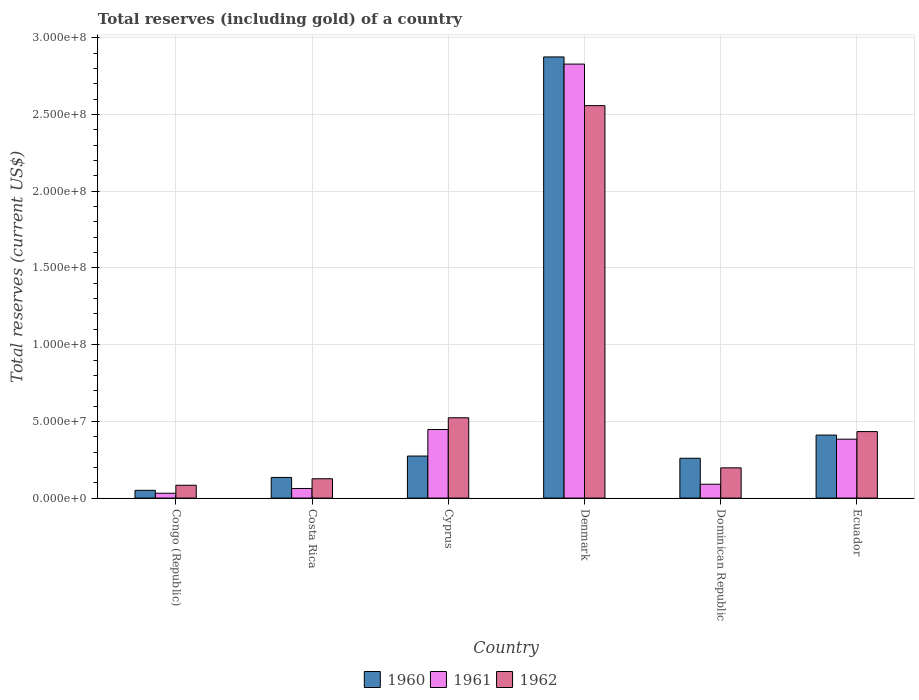How many different coloured bars are there?
Make the answer very short. 3. Are the number of bars on each tick of the X-axis equal?
Offer a terse response. Yes. How many bars are there on the 2nd tick from the right?
Offer a very short reply. 3. What is the label of the 5th group of bars from the left?
Make the answer very short. Dominican Republic. In how many cases, is the number of bars for a given country not equal to the number of legend labels?
Your response must be concise. 0. What is the total reserves (including gold) in 1961 in Denmark?
Your answer should be compact. 2.83e+08. Across all countries, what is the maximum total reserves (including gold) in 1960?
Offer a very short reply. 2.88e+08. Across all countries, what is the minimum total reserves (including gold) in 1960?
Offer a very short reply. 5.06e+06. In which country was the total reserves (including gold) in 1962 minimum?
Your response must be concise. Congo (Republic). What is the total total reserves (including gold) in 1960 in the graph?
Offer a terse response. 4.01e+08. What is the difference between the total reserves (including gold) in 1960 in Congo (Republic) and that in Cyprus?
Give a very brief answer. -2.23e+07. What is the difference between the total reserves (including gold) in 1961 in Ecuador and the total reserves (including gold) in 1962 in Denmark?
Your answer should be compact. -2.17e+08. What is the average total reserves (including gold) in 1961 per country?
Your response must be concise. 6.41e+07. What is the difference between the total reserves (including gold) of/in 1961 and total reserves (including gold) of/in 1962 in Costa Rica?
Offer a terse response. -6.34e+06. In how many countries, is the total reserves (including gold) in 1961 greater than 160000000 US$?
Give a very brief answer. 1. What is the ratio of the total reserves (including gold) in 1960 in Costa Rica to that in Cyprus?
Your answer should be very brief. 0.49. Is the difference between the total reserves (including gold) in 1961 in Denmark and Ecuador greater than the difference between the total reserves (including gold) in 1962 in Denmark and Ecuador?
Your response must be concise. Yes. What is the difference between the highest and the second highest total reserves (including gold) in 1962?
Your answer should be compact. -2.12e+08. What is the difference between the highest and the lowest total reserves (including gold) in 1961?
Ensure brevity in your answer.  2.80e+08. What does the 2nd bar from the right in Dominican Republic represents?
Give a very brief answer. 1961. How many bars are there?
Provide a succinct answer. 18. Are all the bars in the graph horizontal?
Give a very brief answer. No. What is the difference between two consecutive major ticks on the Y-axis?
Your response must be concise. 5.00e+07. Are the values on the major ticks of Y-axis written in scientific E-notation?
Offer a terse response. Yes. How are the legend labels stacked?
Offer a terse response. Horizontal. What is the title of the graph?
Ensure brevity in your answer.  Total reserves (including gold) of a country. What is the label or title of the X-axis?
Keep it short and to the point. Country. What is the label or title of the Y-axis?
Keep it short and to the point. Total reserves (current US$). What is the Total reserves (current US$) in 1960 in Congo (Republic)?
Provide a succinct answer. 5.06e+06. What is the Total reserves (current US$) of 1961 in Congo (Republic)?
Ensure brevity in your answer.  3.16e+06. What is the Total reserves (current US$) of 1962 in Congo (Republic)?
Your answer should be very brief. 8.38e+06. What is the Total reserves (current US$) of 1960 in Costa Rica?
Keep it short and to the point. 1.35e+07. What is the Total reserves (current US$) of 1961 in Costa Rica?
Give a very brief answer. 6.26e+06. What is the Total reserves (current US$) in 1962 in Costa Rica?
Offer a terse response. 1.26e+07. What is the Total reserves (current US$) in 1960 in Cyprus?
Give a very brief answer. 2.74e+07. What is the Total reserves (current US$) in 1961 in Cyprus?
Provide a short and direct response. 4.47e+07. What is the Total reserves (current US$) in 1962 in Cyprus?
Make the answer very short. 5.23e+07. What is the Total reserves (current US$) of 1960 in Denmark?
Ensure brevity in your answer.  2.88e+08. What is the Total reserves (current US$) in 1961 in Denmark?
Provide a succinct answer. 2.83e+08. What is the Total reserves (current US$) in 1962 in Denmark?
Give a very brief answer. 2.56e+08. What is the Total reserves (current US$) of 1960 in Dominican Republic?
Make the answer very short. 2.60e+07. What is the Total reserves (current US$) of 1961 in Dominican Republic?
Provide a short and direct response. 9.02e+06. What is the Total reserves (current US$) of 1962 in Dominican Republic?
Your answer should be very brief. 1.97e+07. What is the Total reserves (current US$) in 1960 in Ecuador?
Your response must be concise. 4.11e+07. What is the Total reserves (current US$) of 1961 in Ecuador?
Offer a terse response. 3.84e+07. What is the Total reserves (current US$) in 1962 in Ecuador?
Provide a succinct answer. 4.33e+07. Across all countries, what is the maximum Total reserves (current US$) in 1960?
Your answer should be compact. 2.88e+08. Across all countries, what is the maximum Total reserves (current US$) in 1961?
Give a very brief answer. 2.83e+08. Across all countries, what is the maximum Total reserves (current US$) in 1962?
Your response must be concise. 2.56e+08. Across all countries, what is the minimum Total reserves (current US$) of 1960?
Offer a very short reply. 5.06e+06. Across all countries, what is the minimum Total reserves (current US$) in 1961?
Make the answer very short. 3.16e+06. Across all countries, what is the minimum Total reserves (current US$) of 1962?
Your answer should be very brief. 8.38e+06. What is the total Total reserves (current US$) in 1960 in the graph?
Make the answer very short. 4.01e+08. What is the total Total reserves (current US$) of 1961 in the graph?
Provide a short and direct response. 3.84e+08. What is the total Total reserves (current US$) in 1962 in the graph?
Provide a succinct answer. 3.92e+08. What is the difference between the Total reserves (current US$) in 1960 in Congo (Republic) and that in Costa Rica?
Give a very brief answer. -8.40e+06. What is the difference between the Total reserves (current US$) in 1961 in Congo (Republic) and that in Costa Rica?
Give a very brief answer. -3.10e+06. What is the difference between the Total reserves (current US$) in 1962 in Congo (Republic) and that in Costa Rica?
Give a very brief answer. -4.22e+06. What is the difference between the Total reserves (current US$) in 1960 in Congo (Republic) and that in Cyprus?
Make the answer very short. -2.23e+07. What is the difference between the Total reserves (current US$) of 1961 in Congo (Republic) and that in Cyprus?
Your answer should be very brief. -4.15e+07. What is the difference between the Total reserves (current US$) of 1962 in Congo (Republic) and that in Cyprus?
Provide a short and direct response. -4.40e+07. What is the difference between the Total reserves (current US$) of 1960 in Congo (Republic) and that in Denmark?
Provide a short and direct response. -2.82e+08. What is the difference between the Total reserves (current US$) of 1961 in Congo (Republic) and that in Denmark?
Your response must be concise. -2.80e+08. What is the difference between the Total reserves (current US$) of 1962 in Congo (Republic) and that in Denmark?
Offer a very short reply. -2.47e+08. What is the difference between the Total reserves (current US$) of 1960 in Congo (Republic) and that in Dominican Republic?
Your answer should be compact. -2.09e+07. What is the difference between the Total reserves (current US$) in 1961 in Congo (Republic) and that in Dominican Republic?
Ensure brevity in your answer.  -5.86e+06. What is the difference between the Total reserves (current US$) in 1962 in Congo (Republic) and that in Dominican Republic?
Ensure brevity in your answer.  -1.13e+07. What is the difference between the Total reserves (current US$) in 1960 in Congo (Republic) and that in Ecuador?
Ensure brevity in your answer.  -3.60e+07. What is the difference between the Total reserves (current US$) in 1961 in Congo (Republic) and that in Ecuador?
Offer a very short reply. -3.52e+07. What is the difference between the Total reserves (current US$) in 1962 in Congo (Republic) and that in Ecuador?
Offer a very short reply. -3.50e+07. What is the difference between the Total reserves (current US$) of 1960 in Costa Rica and that in Cyprus?
Ensure brevity in your answer.  -1.39e+07. What is the difference between the Total reserves (current US$) in 1961 in Costa Rica and that in Cyprus?
Give a very brief answer. -3.84e+07. What is the difference between the Total reserves (current US$) in 1962 in Costa Rica and that in Cyprus?
Provide a succinct answer. -3.98e+07. What is the difference between the Total reserves (current US$) in 1960 in Costa Rica and that in Denmark?
Offer a very short reply. -2.74e+08. What is the difference between the Total reserves (current US$) of 1961 in Costa Rica and that in Denmark?
Offer a very short reply. -2.77e+08. What is the difference between the Total reserves (current US$) in 1962 in Costa Rica and that in Denmark?
Your answer should be very brief. -2.43e+08. What is the difference between the Total reserves (current US$) in 1960 in Costa Rica and that in Dominican Republic?
Your response must be concise. -1.25e+07. What is the difference between the Total reserves (current US$) of 1961 in Costa Rica and that in Dominican Republic?
Offer a very short reply. -2.76e+06. What is the difference between the Total reserves (current US$) of 1962 in Costa Rica and that in Dominican Republic?
Keep it short and to the point. -7.12e+06. What is the difference between the Total reserves (current US$) in 1960 in Costa Rica and that in Ecuador?
Make the answer very short. -2.76e+07. What is the difference between the Total reserves (current US$) in 1961 in Costa Rica and that in Ecuador?
Offer a terse response. -3.21e+07. What is the difference between the Total reserves (current US$) in 1962 in Costa Rica and that in Ecuador?
Provide a succinct answer. -3.07e+07. What is the difference between the Total reserves (current US$) in 1960 in Cyprus and that in Denmark?
Provide a short and direct response. -2.60e+08. What is the difference between the Total reserves (current US$) of 1961 in Cyprus and that in Denmark?
Offer a very short reply. -2.38e+08. What is the difference between the Total reserves (current US$) of 1962 in Cyprus and that in Denmark?
Your response must be concise. -2.03e+08. What is the difference between the Total reserves (current US$) of 1960 in Cyprus and that in Dominican Republic?
Your response must be concise. 1.43e+06. What is the difference between the Total reserves (current US$) in 1961 in Cyprus and that in Dominican Republic?
Keep it short and to the point. 3.57e+07. What is the difference between the Total reserves (current US$) of 1962 in Cyprus and that in Dominican Republic?
Provide a short and direct response. 3.26e+07. What is the difference between the Total reserves (current US$) in 1960 in Cyprus and that in Ecuador?
Provide a succinct answer. -1.37e+07. What is the difference between the Total reserves (current US$) of 1961 in Cyprus and that in Ecuador?
Your answer should be compact. 6.30e+06. What is the difference between the Total reserves (current US$) of 1962 in Cyprus and that in Ecuador?
Ensure brevity in your answer.  9.00e+06. What is the difference between the Total reserves (current US$) in 1960 in Denmark and that in Dominican Republic?
Offer a terse response. 2.62e+08. What is the difference between the Total reserves (current US$) of 1961 in Denmark and that in Dominican Republic?
Make the answer very short. 2.74e+08. What is the difference between the Total reserves (current US$) in 1962 in Denmark and that in Dominican Republic?
Your answer should be very brief. 2.36e+08. What is the difference between the Total reserves (current US$) of 1960 in Denmark and that in Ecuador?
Provide a succinct answer. 2.46e+08. What is the difference between the Total reserves (current US$) of 1961 in Denmark and that in Ecuador?
Provide a short and direct response. 2.44e+08. What is the difference between the Total reserves (current US$) of 1962 in Denmark and that in Ecuador?
Make the answer very short. 2.12e+08. What is the difference between the Total reserves (current US$) in 1960 in Dominican Republic and that in Ecuador?
Keep it short and to the point. -1.51e+07. What is the difference between the Total reserves (current US$) of 1961 in Dominican Republic and that in Ecuador?
Offer a terse response. -2.94e+07. What is the difference between the Total reserves (current US$) in 1962 in Dominican Republic and that in Ecuador?
Offer a terse response. -2.36e+07. What is the difference between the Total reserves (current US$) in 1960 in Congo (Republic) and the Total reserves (current US$) in 1961 in Costa Rica?
Give a very brief answer. -1.20e+06. What is the difference between the Total reserves (current US$) in 1960 in Congo (Republic) and the Total reserves (current US$) in 1962 in Costa Rica?
Ensure brevity in your answer.  -7.54e+06. What is the difference between the Total reserves (current US$) of 1961 in Congo (Republic) and the Total reserves (current US$) of 1962 in Costa Rica?
Your response must be concise. -9.44e+06. What is the difference between the Total reserves (current US$) of 1960 in Congo (Republic) and the Total reserves (current US$) of 1961 in Cyprus?
Ensure brevity in your answer.  -3.96e+07. What is the difference between the Total reserves (current US$) in 1960 in Congo (Republic) and the Total reserves (current US$) in 1962 in Cyprus?
Your response must be concise. -4.73e+07. What is the difference between the Total reserves (current US$) of 1961 in Congo (Republic) and the Total reserves (current US$) of 1962 in Cyprus?
Offer a very short reply. -4.92e+07. What is the difference between the Total reserves (current US$) of 1960 in Congo (Republic) and the Total reserves (current US$) of 1961 in Denmark?
Make the answer very short. -2.78e+08. What is the difference between the Total reserves (current US$) in 1960 in Congo (Republic) and the Total reserves (current US$) in 1962 in Denmark?
Your answer should be very brief. -2.51e+08. What is the difference between the Total reserves (current US$) in 1961 in Congo (Republic) and the Total reserves (current US$) in 1962 in Denmark?
Ensure brevity in your answer.  -2.53e+08. What is the difference between the Total reserves (current US$) in 1960 in Congo (Republic) and the Total reserves (current US$) in 1961 in Dominican Republic?
Offer a very short reply. -3.96e+06. What is the difference between the Total reserves (current US$) in 1960 in Congo (Republic) and the Total reserves (current US$) in 1962 in Dominican Republic?
Make the answer very short. -1.47e+07. What is the difference between the Total reserves (current US$) of 1961 in Congo (Republic) and the Total reserves (current US$) of 1962 in Dominican Republic?
Offer a very short reply. -1.66e+07. What is the difference between the Total reserves (current US$) of 1960 in Congo (Republic) and the Total reserves (current US$) of 1961 in Ecuador?
Your answer should be very brief. -3.33e+07. What is the difference between the Total reserves (current US$) of 1960 in Congo (Republic) and the Total reserves (current US$) of 1962 in Ecuador?
Your answer should be compact. -3.83e+07. What is the difference between the Total reserves (current US$) of 1961 in Congo (Republic) and the Total reserves (current US$) of 1962 in Ecuador?
Your response must be concise. -4.02e+07. What is the difference between the Total reserves (current US$) of 1960 in Costa Rica and the Total reserves (current US$) of 1961 in Cyprus?
Your response must be concise. -3.12e+07. What is the difference between the Total reserves (current US$) in 1960 in Costa Rica and the Total reserves (current US$) in 1962 in Cyprus?
Make the answer very short. -3.89e+07. What is the difference between the Total reserves (current US$) of 1961 in Costa Rica and the Total reserves (current US$) of 1962 in Cyprus?
Give a very brief answer. -4.61e+07. What is the difference between the Total reserves (current US$) in 1960 in Costa Rica and the Total reserves (current US$) in 1961 in Denmark?
Offer a very short reply. -2.69e+08. What is the difference between the Total reserves (current US$) in 1960 in Costa Rica and the Total reserves (current US$) in 1962 in Denmark?
Keep it short and to the point. -2.42e+08. What is the difference between the Total reserves (current US$) in 1961 in Costa Rica and the Total reserves (current US$) in 1962 in Denmark?
Ensure brevity in your answer.  -2.50e+08. What is the difference between the Total reserves (current US$) in 1960 in Costa Rica and the Total reserves (current US$) in 1961 in Dominican Republic?
Your answer should be very brief. 4.44e+06. What is the difference between the Total reserves (current US$) of 1960 in Costa Rica and the Total reserves (current US$) of 1962 in Dominican Republic?
Ensure brevity in your answer.  -6.26e+06. What is the difference between the Total reserves (current US$) of 1961 in Costa Rica and the Total reserves (current US$) of 1962 in Dominican Republic?
Your answer should be compact. -1.35e+07. What is the difference between the Total reserves (current US$) in 1960 in Costa Rica and the Total reserves (current US$) in 1961 in Ecuador?
Your response must be concise. -2.49e+07. What is the difference between the Total reserves (current US$) of 1960 in Costa Rica and the Total reserves (current US$) of 1962 in Ecuador?
Your answer should be very brief. -2.99e+07. What is the difference between the Total reserves (current US$) in 1961 in Costa Rica and the Total reserves (current US$) in 1962 in Ecuador?
Offer a terse response. -3.71e+07. What is the difference between the Total reserves (current US$) in 1960 in Cyprus and the Total reserves (current US$) in 1961 in Denmark?
Give a very brief answer. -2.55e+08. What is the difference between the Total reserves (current US$) of 1960 in Cyprus and the Total reserves (current US$) of 1962 in Denmark?
Your answer should be very brief. -2.28e+08. What is the difference between the Total reserves (current US$) in 1961 in Cyprus and the Total reserves (current US$) in 1962 in Denmark?
Keep it short and to the point. -2.11e+08. What is the difference between the Total reserves (current US$) of 1960 in Cyprus and the Total reserves (current US$) of 1961 in Dominican Republic?
Make the answer very short. 1.84e+07. What is the difference between the Total reserves (current US$) in 1960 in Cyprus and the Total reserves (current US$) in 1962 in Dominican Republic?
Your answer should be very brief. 7.68e+06. What is the difference between the Total reserves (current US$) in 1961 in Cyprus and the Total reserves (current US$) in 1962 in Dominican Republic?
Make the answer very short. 2.50e+07. What is the difference between the Total reserves (current US$) in 1960 in Cyprus and the Total reserves (current US$) in 1961 in Ecuador?
Provide a succinct answer. -1.10e+07. What is the difference between the Total reserves (current US$) of 1960 in Cyprus and the Total reserves (current US$) of 1962 in Ecuador?
Ensure brevity in your answer.  -1.59e+07. What is the difference between the Total reserves (current US$) of 1961 in Cyprus and the Total reserves (current US$) of 1962 in Ecuador?
Your answer should be very brief. 1.35e+06. What is the difference between the Total reserves (current US$) of 1960 in Denmark and the Total reserves (current US$) of 1961 in Dominican Republic?
Make the answer very short. 2.79e+08. What is the difference between the Total reserves (current US$) in 1960 in Denmark and the Total reserves (current US$) in 1962 in Dominican Republic?
Your answer should be very brief. 2.68e+08. What is the difference between the Total reserves (current US$) of 1961 in Denmark and the Total reserves (current US$) of 1962 in Dominican Republic?
Keep it short and to the point. 2.63e+08. What is the difference between the Total reserves (current US$) of 1960 in Denmark and the Total reserves (current US$) of 1961 in Ecuador?
Keep it short and to the point. 2.49e+08. What is the difference between the Total reserves (current US$) in 1960 in Denmark and the Total reserves (current US$) in 1962 in Ecuador?
Keep it short and to the point. 2.44e+08. What is the difference between the Total reserves (current US$) in 1961 in Denmark and the Total reserves (current US$) in 1962 in Ecuador?
Make the answer very short. 2.40e+08. What is the difference between the Total reserves (current US$) in 1960 in Dominican Republic and the Total reserves (current US$) in 1961 in Ecuador?
Offer a very short reply. -1.24e+07. What is the difference between the Total reserves (current US$) in 1960 in Dominican Republic and the Total reserves (current US$) in 1962 in Ecuador?
Your answer should be very brief. -1.74e+07. What is the difference between the Total reserves (current US$) in 1961 in Dominican Republic and the Total reserves (current US$) in 1962 in Ecuador?
Your answer should be very brief. -3.43e+07. What is the average Total reserves (current US$) of 1960 per country?
Provide a succinct answer. 6.68e+07. What is the average Total reserves (current US$) of 1961 per country?
Ensure brevity in your answer.  6.41e+07. What is the average Total reserves (current US$) in 1962 per country?
Offer a very short reply. 6.54e+07. What is the difference between the Total reserves (current US$) of 1960 and Total reserves (current US$) of 1961 in Congo (Republic)?
Give a very brief answer. 1.90e+06. What is the difference between the Total reserves (current US$) of 1960 and Total reserves (current US$) of 1962 in Congo (Republic)?
Ensure brevity in your answer.  -3.32e+06. What is the difference between the Total reserves (current US$) in 1961 and Total reserves (current US$) in 1962 in Congo (Republic)?
Your response must be concise. -5.22e+06. What is the difference between the Total reserves (current US$) in 1960 and Total reserves (current US$) in 1961 in Costa Rica?
Provide a short and direct response. 7.20e+06. What is the difference between the Total reserves (current US$) of 1960 and Total reserves (current US$) of 1962 in Costa Rica?
Make the answer very short. 8.62e+05. What is the difference between the Total reserves (current US$) of 1961 and Total reserves (current US$) of 1962 in Costa Rica?
Provide a succinct answer. -6.34e+06. What is the difference between the Total reserves (current US$) of 1960 and Total reserves (current US$) of 1961 in Cyprus?
Give a very brief answer. -1.73e+07. What is the difference between the Total reserves (current US$) in 1960 and Total reserves (current US$) in 1962 in Cyprus?
Keep it short and to the point. -2.49e+07. What is the difference between the Total reserves (current US$) of 1961 and Total reserves (current US$) of 1962 in Cyprus?
Offer a terse response. -7.65e+06. What is the difference between the Total reserves (current US$) in 1960 and Total reserves (current US$) in 1961 in Denmark?
Provide a succinct answer. 4.67e+06. What is the difference between the Total reserves (current US$) of 1960 and Total reserves (current US$) of 1962 in Denmark?
Offer a very short reply. 3.17e+07. What is the difference between the Total reserves (current US$) in 1961 and Total reserves (current US$) in 1962 in Denmark?
Offer a very short reply. 2.71e+07. What is the difference between the Total reserves (current US$) in 1960 and Total reserves (current US$) in 1961 in Dominican Republic?
Your answer should be very brief. 1.70e+07. What is the difference between the Total reserves (current US$) of 1960 and Total reserves (current US$) of 1962 in Dominican Republic?
Your response must be concise. 6.26e+06. What is the difference between the Total reserves (current US$) of 1961 and Total reserves (current US$) of 1962 in Dominican Republic?
Keep it short and to the point. -1.07e+07. What is the difference between the Total reserves (current US$) in 1960 and Total reserves (current US$) in 1961 in Ecuador?
Offer a very short reply. 2.68e+06. What is the difference between the Total reserves (current US$) in 1960 and Total reserves (current US$) in 1962 in Ecuador?
Your answer should be compact. -2.27e+06. What is the difference between the Total reserves (current US$) of 1961 and Total reserves (current US$) of 1962 in Ecuador?
Offer a terse response. -4.95e+06. What is the ratio of the Total reserves (current US$) of 1960 in Congo (Republic) to that in Costa Rica?
Keep it short and to the point. 0.38. What is the ratio of the Total reserves (current US$) of 1961 in Congo (Republic) to that in Costa Rica?
Provide a short and direct response. 0.5. What is the ratio of the Total reserves (current US$) in 1962 in Congo (Republic) to that in Costa Rica?
Provide a short and direct response. 0.67. What is the ratio of the Total reserves (current US$) in 1960 in Congo (Republic) to that in Cyprus?
Keep it short and to the point. 0.18. What is the ratio of the Total reserves (current US$) of 1961 in Congo (Republic) to that in Cyprus?
Provide a short and direct response. 0.07. What is the ratio of the Total reserves (current US$) of 1962 in Congo (Republic) to that in Cyprus?
Provide a short and direct response. 0.16. What is the ratio of the Total reserves (current US$) of 1960 in Congo (Republic) to that in Denmark?
Ensure brevity in your answer.  0.02. What is the ratio of the Total reserves (current US$) in 1961 in Congo (Republic) to that in Denmark?
Give a very brief answer. 0.01. What is the ratio of the Total reserves (current US$) of 1962 in Congo (Republic) to that in Denmark?
Ensure brevity in your answer.  0.03. What is the ratio of the Total reserves (current US$) in 1960 in Congo (Republic) to that in Dominican Republic?
Keep it short and to the point. 0.19. What is the ratio of the Total reserves (current US$) of 1961 in Congo (Republic) to that in Dominican Republic?
Offer a very short reply. 0.35. What is the ratio of the Total reserves (current US$) of 1962 in Congo (Republic) to that in Dominican Republic?
Offer a terse response. 0.42. What is the ratio of the Total reserves (current US$) in 1960 in Congo (Republic) to that in Ecuador?
Provide a succinct answer. 0.12. What is the ratio of the Total reserves (current US$) in 1961 in Congo (Republic) to that in Ecuador?
Ensure brevity in your answer.  0.08. What is the ratio of the Total reserves (current US$) in 1962 in Congo (Republic) to that in Ecuador?
Your response must be concise. 0.19. What is the ratio of the Total reserves (current US$) in 1960 in Costa Rica to that in Cyprus?
Keep it short and to the point. 0.49. What is the ratio of the Total reserves (current US$) of 1961 in Costa Rica to that in Cyprus?
Make the answer very short. 0.14. What is the ratio of the Total reserves (current US$) of 1962 in Costa Rica to that in Cyprus?
Keep it short and to the point. 0.24. What is the ratio of the Total reserves (current US$) of 1960 in Costa Rica to that in Denmark?
Your answer should be compact. 0.05. What is the ratio of the Total reserves (current US$) in 1961 in Costa Rica to that in Denmark?
Ensure brevity in your answer.  0.02. What is the ratio of the Total reserves (current US$) in 1962 in Costa Rica to that in Denmark?
Offer a terse response. 0.05. What is the ratio of the Total reserves (current US$) in 1960 in Costa Rica to that in Dominican Republic?
Keep it short and to the point. 0.52. What is the ratio of the Total reserves (current US$) in 1961 in Costa Rica to that in Dominican Republic?
Keep it short and to the point. 0.69. What is the ratio of the Total reserves (current US$) of 1962 in Costa Rica to that in Dominican Republic?
Your response must be concise. 0.64. What is the ratio of the Total reserves (current US$) in 1960 in Costa Rica to that in Ecuador?
Give a very brief answer. 0.33. What is the ratio of the Total reserves (current US$) in 1961 in Costa Rica to that in Ecuador?
Give a very brief answer. 0.16. What is the ratio of the Total reserves (current US$) in 1962 in Costa Rica to that in Ecuador?
Offer a terse response. 0.29. What is the ratio of the Total reserves (current US$) in 1960 in Cyprus to that in Denmark?
Give a very brief answer. 0.1. What is the ratio of the Total reserves (current US$) in 1961 in Cyprus to that in Denmark?
Your answer should be compact. 0.16. What is the ratio of the Total reserves (current US$) in 1962 in Cyprus to that in Denmark?
Your response must be concise. 0.2. What is the ratio of the Total reserves (current US$) in 1960 in Cyprus to that in Dominican Republic?
Make the answer very short. 1.05. What is the ratio of the Total reserves (current US$) in 1961 in Cyprus to that in Dominican Republic?
Offer a very short reply. 4.95. What is the ratio of the Total reserves (current US$) in 1962 in Cyprus to that in Dominican Republic?
Provide a succinct answer. 2.66. What is the ratio of the Total reserves (current US$) of 1960 in Cyprus to that in Ecuador?
Provide a succinct answer. 0.67. What is the ratio of the Total reserves (current US$) in 1961 in Cyprus to that in Ecuador?
Your answer should be compact. 1.16. What is the ratio of the Total reserves (current US$) of 1962 in Cyprus to that in Ecuador?
Offer a very short reply. 1.21. What is the ratio of the Total reserves (current US$) of 1960 in Denmark to that in Dominican Republic?
Offer a terse response. 11.07. What is the ratio of the Total reserves (current US$) of 1961 in Denmark to that in Dominican Republic?
Offer a terse response. 31.35. What is the ratio of the Total reserves (current US$) in 1962 in Denmark to that in Dominican Republic?
Make the answer very short. 12.97. What is the ratio of the Total reserves (current US$) of 1960 in Denmark to that in Ecuador?
Your answer should be compact. 7. What is the ratio of the Total reserves (current US$) of 1961 in Denmark to that in Ecuador?
Give a very brief answer. 7.37. What is the ratio of the Total reserves (current US$) of 1962 in Denmark to that in Ecuador?
Provide a short and direct response. 5.9. What is the ratio of the Total reserves (current US$) of 1960 in Dominican Republic to that in Ecuador?
Ensure brevity in your answer.  0.63. What is the ratio of the Total reserves (current US$) in 1961 in Dominican Republic to that in Ecuador?
Ensure brevity in your answer.  0.23. What is the ratio of the Total reserves (current US$) of 1962 in Dominican Republic to that in Ecuador?
Make the answer very short. 0.45. What is the difference between the highest and the second highest Total reserves (current US$) in 1960?
Keep it short and to the point. 2.46e+08. What is the difference between the highest and the second highest Total reserves (current US$) of 1961?
Provide a short and direct response. 2.38e+08. What is the difference between the highest and the second highest Total reserves (current US$) in 1962?
Provide a succinct answer. 2.03e+08. What is the difference between the highest and the lowest Total reserves (current US$) of 1960?
Offer a terse response. 2.82e+08. What is the difference between the highest and the lowest Total reserves (current US$) in 1961?
Offer a terse response. 2.80e+08. What is the difference between the highest and the lowest Total reserves (current US$) of 1962?
Keep it short and to the point. 2.47e+08. 